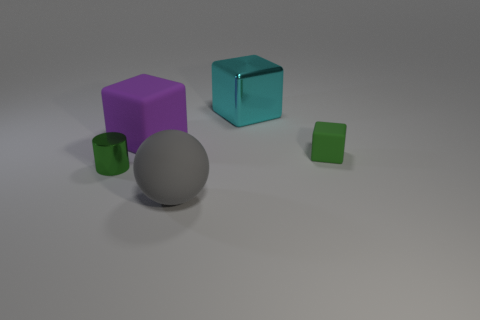What is the material of the thing that is the same color as the metal cylinder?
Make the answer very short. Rubber. There is a tiny block; is it the same color as the metal thing that is on the left side of the large cyan cube?
Your answer should be very brief. Yes. The other purple thing that is the same shape as the small rubber thing is what size?
Ensure brevity in your answer.  Large. Is the cylinder the same color as the small cube?
Provide a short and direct response. Yes. The tiny green thing that is to the left of the shiny object behind the green thing in front of the tiny green rubber thing is what shape?
Provide a succinct answer. Cylinder. How many other things are the same color as the tiny shiny thing?
Provide a succinct answer. 1. What is the shape of the small object that is on the left side of the big object that is in front of the tiny cylinder?
Make the answer very short. Cylinder. How many tiny green matte blocks are in front of the large matte ball?
Give a very brief answer. 0. Are there any purple things that have the same material as the large sphere?
Provide a succinct answer. Yes. There is a purple cube that is the same size as the gray ball; what material is it?
Make the answer very short. Rubber. 